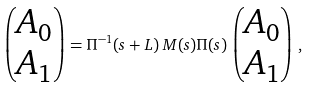Convert formula to latex. <formula><loc_0><loc_0><loc_500><loc_500>\begin{pmatrix} A _ { 0 } \\ A _ { 1 } \end{pmatrix} = \Pi ^ { - 1 } ( s + L ) \, M ( s ) \Pi ( s ) \, \begin{pmatrix} A _ { 0 } \\ A _ { 1 } \end{pmatrix} \, ,</formula> 